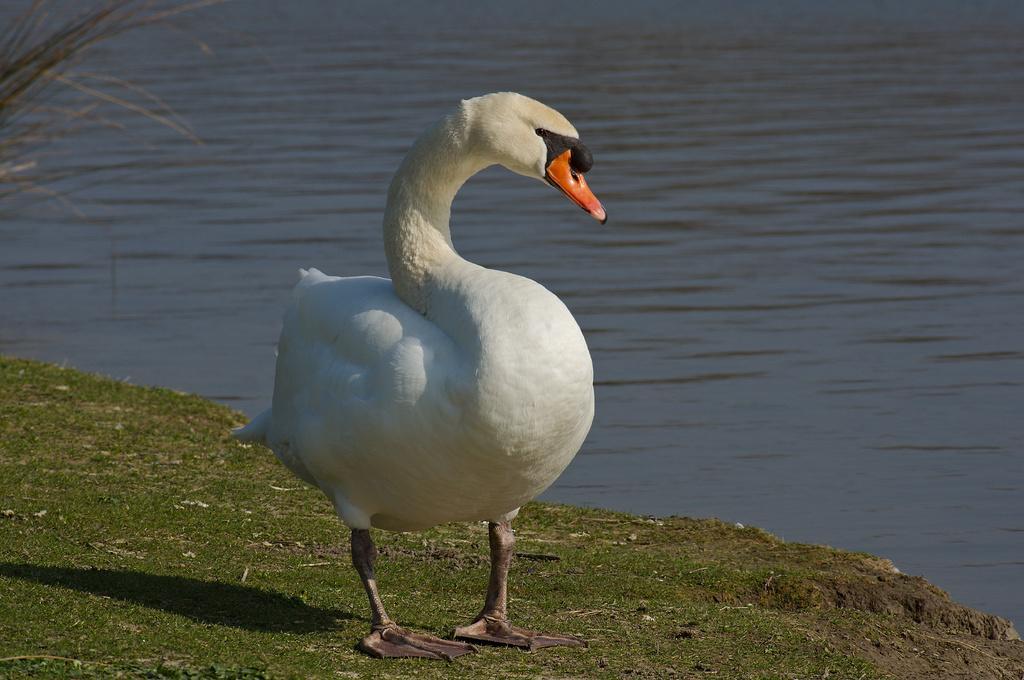How would you summarize this image in a sentence or two? There is a swan on the grass. In the background there is water. 